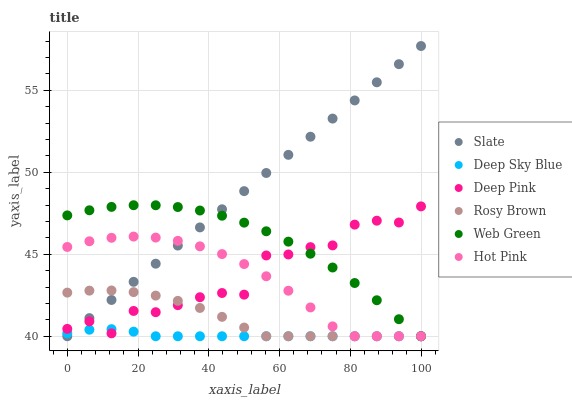Does Deep Sky Blue have the minimum area under the curve?
Answer yes or no. Yes. Does Slate have the maximum area under the curve?
Answer yes or no. Yes. Does Rosy Brown have the minimum area under the curve?
Answer yes or no. No. Does Rosy Brown have the maximum area under the curve?
Answer yes or no. No. Is Slate the smoothest?
Answer yes or no. Yes. Is Deep Pink the roughest?
Answer yes or no. Yes. Is Rosy Brown the smoothest?
Answer yes or no. No. Is Rosy Brown the roughest?
Answer yes or no. No. Does Slate have the lowest value?
Answer yes or no. Yes. Does Slate have the highest value?
Answer yes or no. Yes. Does Rosy Brown have the highest value?
Answer yes or no. No. Does Slate intersect Deep Sky Blue?
Answer yes or no. Yes. Is Slate less than Deep Sky Blue?
Answer yes or no. No. Is Slate greater than Deep Sky Blue?
Answer yes or no. No. 